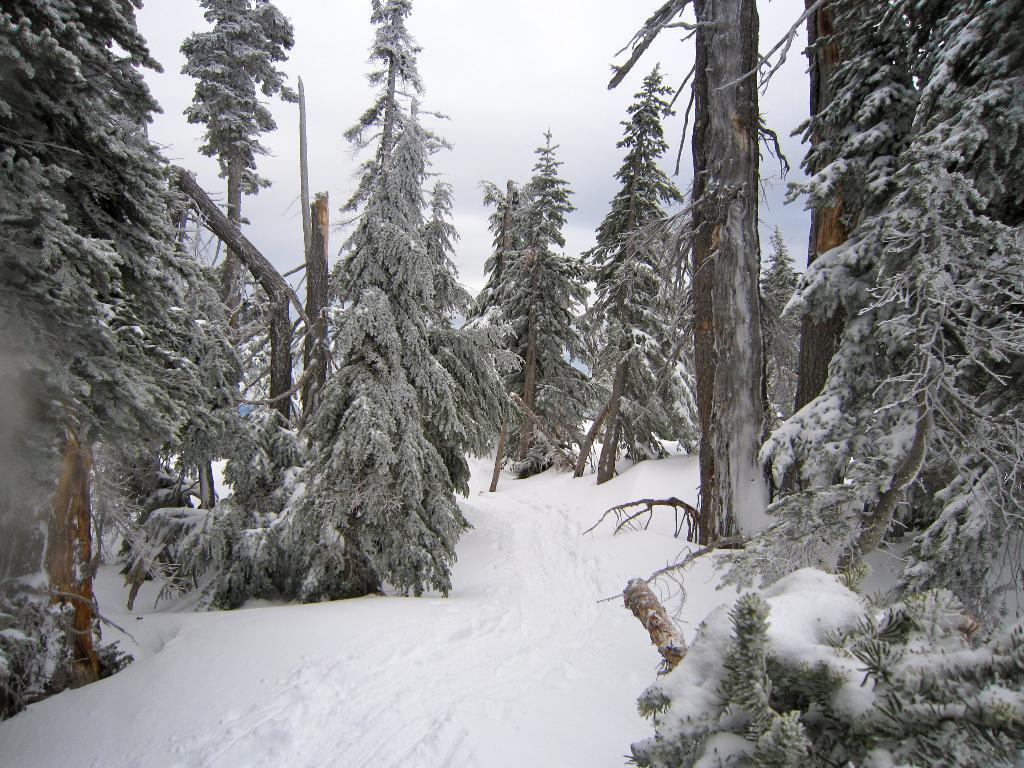What type of vegetation can be seen in the image? There are trees in the image. What is covering the ground in the image? There is snow visible in the image. What part of the natural environment is visible in the image? The sky is visible in the image. What scientific discovery can be seen in the image? There is no scientific discovery present in the image; it features trees, snow, and the sky. What type of tub is visible in the image? There is no tub present in the image. 